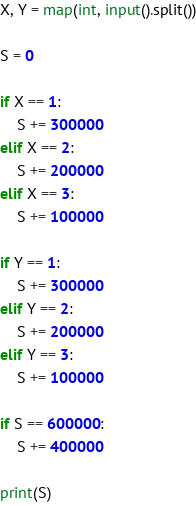Convert code to text. <code><loc_0><loc_0><loc_500><loc_500><_Python_>X, Y = map(int, input().split())

S = 0

if X == 1:
    S += 300000
elif X == 2:
    S += 200000
elif X == 3:
    S += 100000

if Y == 1:
    S += 300000
elif Y == 2:
    S += 200000
elif Y == 3:
    S += 100000

if S == 600000:
    S += 400000

print(S)</code> 